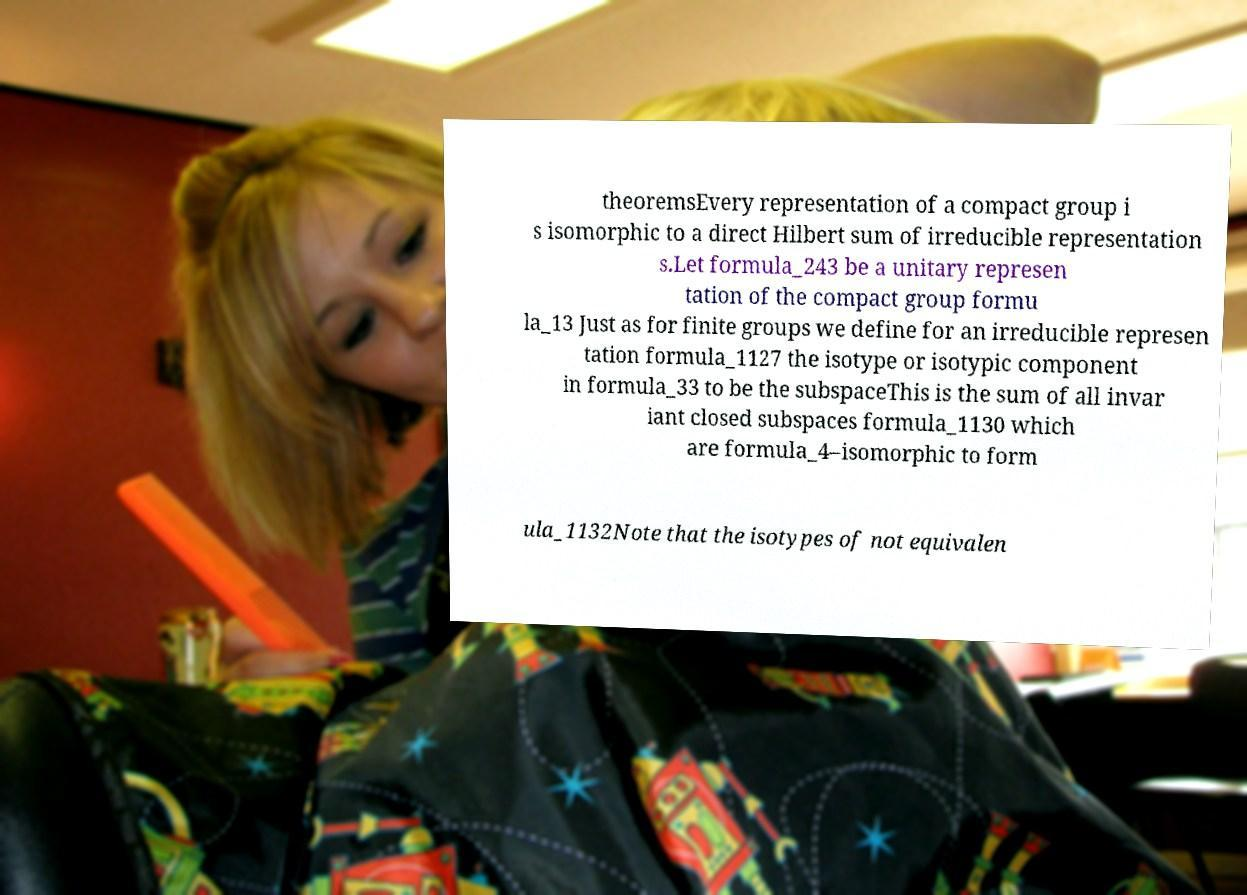Could you assist in decoding the text presented in this image and type it out clearly? theoremsEvery representation of a compact group i s isomorphic to a direct Hilbert sum of irreducible representation s.Let formula_243 be a unitary represen tation of the compact group formu la_13 Just as for finite groups we define for an irreducible represen tation formula_1127 the isotype or isotypic component in formula_33 to be the subspaceThis is the sum of all invar iant closed subspaces formula_1130 which are formula_4–isomorphic to form ula_1132Note that the isotypes of not equivalen 